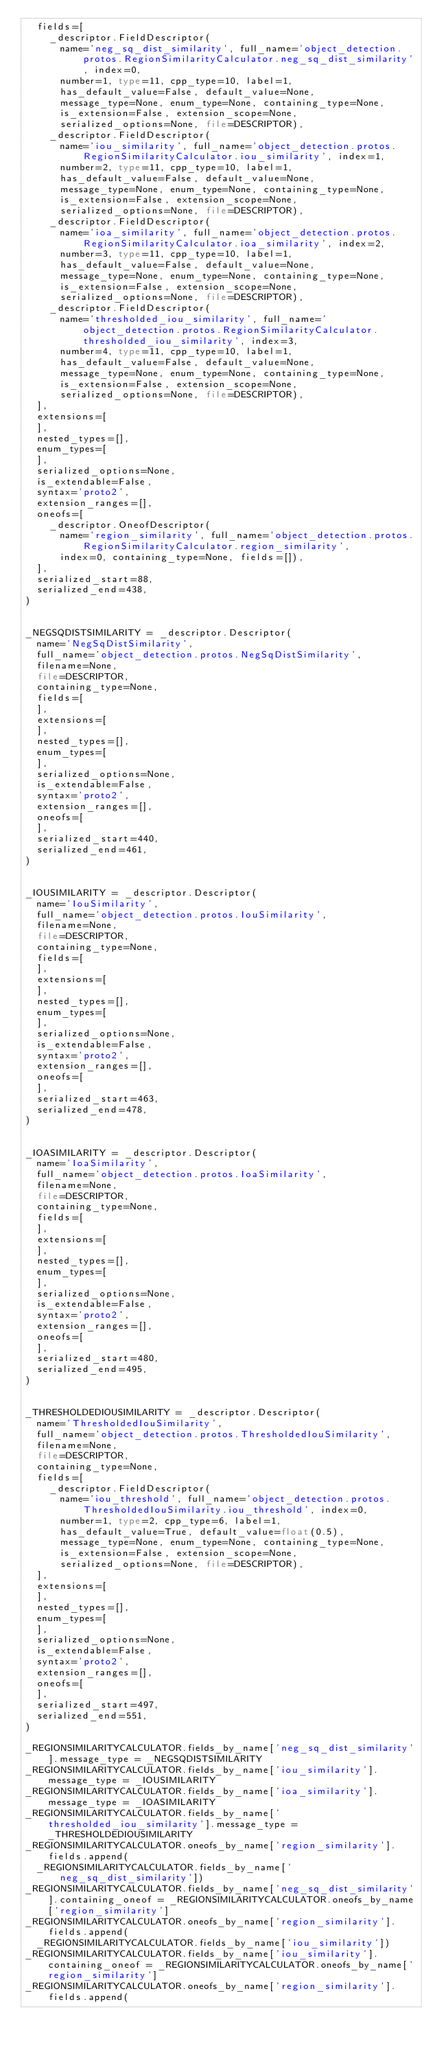<code> <loc_0><loc_0><loc_500><loc_500><_Python_>  fields=[
    _descriptor.FieldDescriptor(
      name='neg_sq_dist_similarity', full_name='object_detection.protos.RegionSimilarityCalculator.neg_sq_dist_similarity', index=0,
      number=1, type=11, cpp_type=10, label=1,
      has_default_value=False, default_value=None,
      message_type=None, enum_type=None, containing_type=None,
      is_extension=False, extension_scope=None,
      serialized_options=None, file=DESCRIPTOR),
    _descriptor.FieldDescriptor(
      name='iou_similarity', full_name='object_detection.protos.RegionSimilarityCalculator.iou_similarity', index=1,
      number=2, type=11, cpp_type=10, label=1,
      has_default_value=False, default_value=None,
      message_type=None, enum_type=None, containing_type=None,
      is_extension=False, extension_scope=None,
      serialized_options=None, file=DESCRIPTOR),
    _descriptor.FieldDescriptor(
      name='ioa_similarity', full_name='object_detection.protos.RegionSimilarityCalculator.ioa_similarity', index=2,
      number=3, type=11, cpp_type=10, label=1,
      has_default_value=False, default_value=None,
      message_type=None, enum_type=None, containing_type=None,
      is_extension=False, extension_scope=None,
      serialized_options=None, file=DESCRIPTOR),
    _descriptor.FieldDescriptor(
      name='thresholded_iou_similarity', full_name='object_detection.protos.RegionSimilarityCalculator.thresholded_iou_similarity', index=3,
      number=4, type=11, cpp_type=10, label=1,
      has_default_value=False, default_value=None,
      message_type=None, enum_type=None, containing_type=None,
      is_extension=False, extension_scope=None,
      serialized_options=None, file=DESCRIPTOR),
  ],
  extensions=[
  ],
  nested_types=[],
  enum_types=[
  ],
  serialized_options=None,
  is_extendable=False,
  syntax='proto2',
  extension_ranges=[],
  oneofs=[
    _descriptor.OneofDescriptor(
      name='region_similarity', full_name='object_detection.protos.RegionSimilarityCalculator.region_similarity',
      index=0, containing_type=None, fields=[]),
  ],
  serialized_start=88,
  serialized_end=438,
)


_NEGSQDISTSIMILARITY = _descriptor.Descriptor(
  name='NegSqDistSimilarity',
  full_name='object_detection.protos.NegSqDistSimilarity',
  filename=None,
  file=DESCRIPTOR,
  containing_type=None,
  fields=[
  ],
  extensions=[
  ],
  nested_types=[],
  enum_types=[
  ],
  serialized_options=None,
  is_extendable=False,
  syntax='proto2',
  extension_ranges=[],
  oneofs=[
  ],
  serialized_start=440,
  serialized_end=461,
)


_IOUSIMILARITY = _descriptor.Descriptor(
  name='IouSimilarity',
  full_name='object_detection.protos.IouSimilarity',
  filename=None,
  file=DESCRIPTOR,
  containing_type=None,
  fields=[
  ],
  extensions=[
  ],
  nested_types=[],
  enum_types=[
  ],
  serialized_options=None,
  is_extendable=False,
  syntax='proto2',
  extension_ranges=[],
  oneofs=[
  ],
  serialized_start=463,
  serialized_end=478,
)


_IOASIMILARITY = _descriptor.Descriptor(
  name='IoaSimilarity',
  full_name='object_detection.protos.IoaSimilarity',
  filename=None,
  file=DESCRIPTOR,
  containing_type=None,
  fields=[
  ],
  extensions=[
  ],
  nested_types=[],
  enum_types=[
  ],
  serialized_options=None,
  is_extendable=False,
  syntax='proto2',
  extension_ranges=[],
  oneofs=[
  ],
  serialized_start=480,
  serialized_end=495,
)


_THRESHOLDEDIOUSIMILARITY = _descriptor.Descriptor(
  name='ThresholdedIouSimilarity',
  full_name='object_detection.protos.ThresholdedIouSimilarity',
  filename=None,
  file=DESCRIPTOR,
  containing_type=None,
  fields=[
    _descriptor.FieldDescriptor(
      name='iou_threshold', full_name='object_detection.protos.ThresholdedIouSimilarity.iou_threshold', index=0,
      number=1, type=2, cpp_type=6, label=1,
      has_default_value=True, default_value=float(0.5),
      message_type=None, enum_type=None, containing_type=None,
      is_extension=False, extension_scope=None,
      serialized_options=None, file=DESCRIPTOR),
  ],
  extensions=[
  ],
  nested_types=[],
  enum_types=[
  ],
  serialized_options=None,
  is_extendable=False,
  syntax='proto2',
  extension_ranges=[],
  oneofs=[
  ],
  serialized_start=497,
  serialized_end=551,
)

_REGIONSIMILARITYCALCULATOR.fields_by_name['neg_sq_dist_similarity'].message_type = _NEGSQDISTSIMILARITY
_REGIONSIMILARITYCALCULATOR.fields_by_name['iou_similarity'].message_type = _IOUSIMILARITY
_REGIONSIMILARITYCALCULATOR.fields_by_name['ioa_similarity'].message_type = _IOASIMILARITY
_REGIONSIMILARITYCALCULATOR.fields_by_name['thresholded_iou_similarity'].message_type = _THRESHOLDEDIOUSIMILARITY
_REGIONSIMILARITYCALCULATOR.oneofs_by_name['region_similarity'].fields.append(
  _REGIONSIMILARITYCALCULATOR.fields_by_name['neg_sq_dist_similarity'])
_REGIONSIMILARITYCALCULATOR.fields_by_name['neg_sq_dist_similarity'].containing_oneof = _REGIONSIMILARITYCALCULATOR.oneofs_by_name['region_similarity']
_REGIONSIMILARITYCALCULATOR.oneofs_by_name['region_similarity'].fields.append(
  _REGIONSIMILARITYCALCULATOR.fields_by_name['iou_similarity'])
_REGIONSIMILARITYCALCULATOR.fields_by_name['iou_similarity'].containing_oneof = _REGIONSIMILARITYCALCULATOR.oneofs_by_name['region_similarity']
_REGIONSIMILARITYCALCULATOR.oneofs_by_name['region_similarity'].fields.append(</code> 